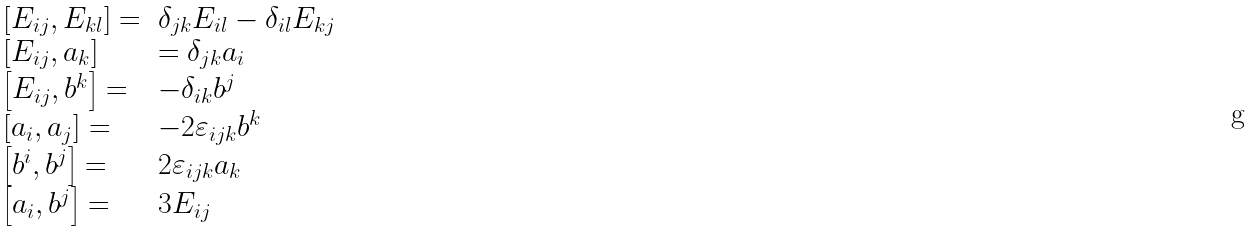<formula> <loc_0><loc_0><loc_500><loc_500>\begin{array} { l l } \left [ E _ { i j } , E _ { k l } \right ] = & \delta _ { j k } E _ { i l } - \delta _ { i l } E _ { k j } \\ \left [ E _ { i j } , a _ { k } \right ] & = \delta _ { j k } a _ { i } \\ \left [ E _ { i j } , b ^ { k } \right ] = & - \delta _ { i k } b ^ { j } \\ \left [ a _ { i } , a _ { j } \right ] = & - 2 \varepsilon _ { i j k } b ^ { k } \\ \left [ b ^ { i } , b ^ { j } \right ] = & 2 \varepsilon _ { i j k } a _ { k } \\ \left [ a _ { i } , b ^ { j } \right ] = & 3 E _ { i j } \end{array}</formula> 